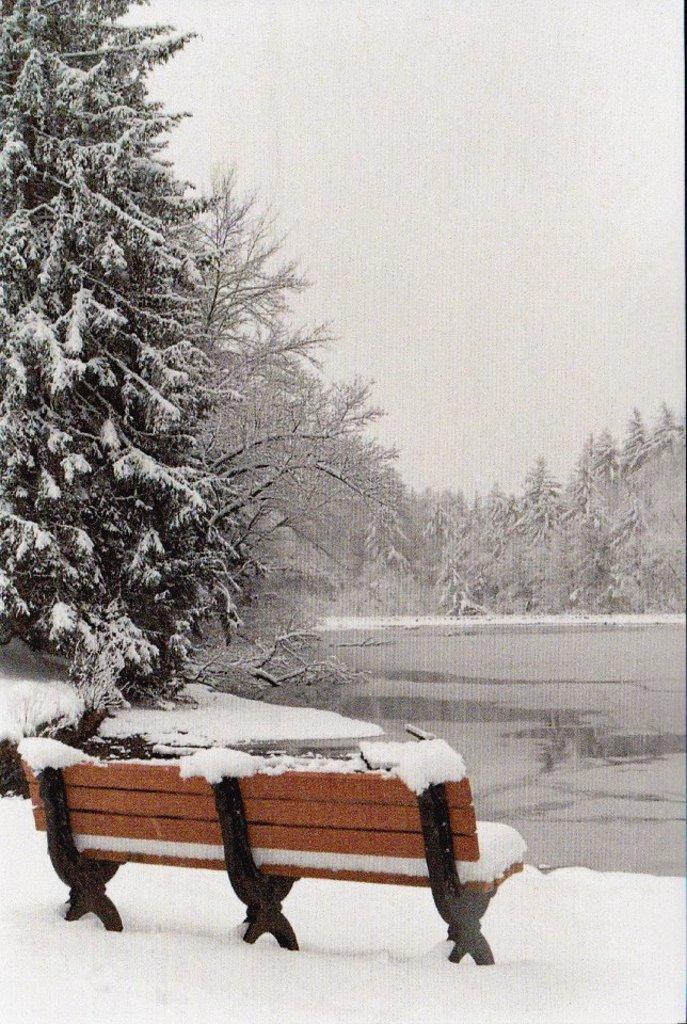Please provide a concise description of this image. In this image we can see a bench placed in snow. In the background, we can see water, group of trees and the sky. 